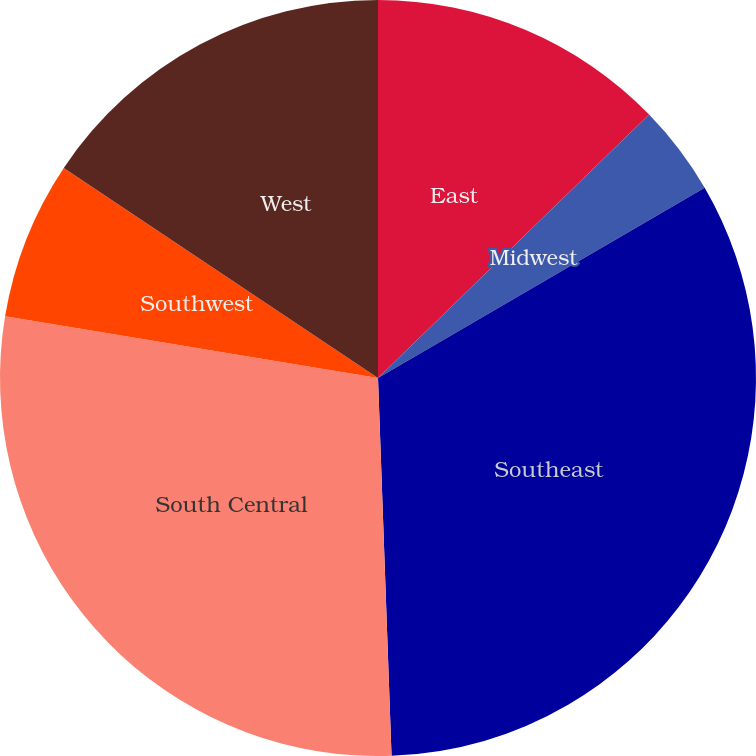<chart> <loc_0><loc_0><loc_500><loc_500><pie_chart><fcel>East<fcel>Midwest<fcel>Southeast<fcel>South Central<fcel>Southwest<fcel>West<nl><fcel>12.73%<fcel>3.88%<fcel>32.82%<fcel>28.18%<fcel>6.77%<fcel>15.62%<nl></chart> 